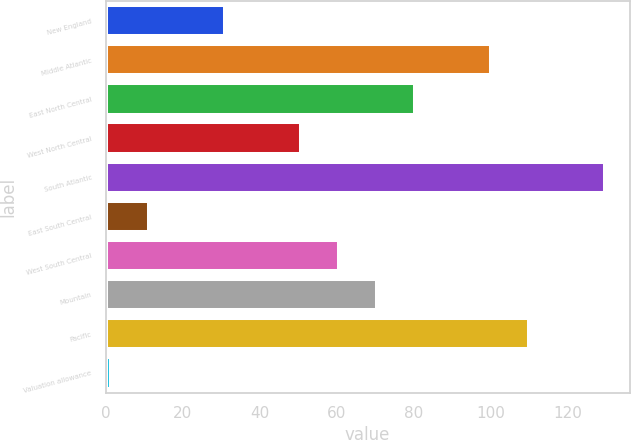Convert chart. <chart><loc_0><loc_0><loc_500><loc_500><bar_chart><fcel>New England<fcel>Middle Atlantic<fcel>East North Central<fcel>West North Central<fcel>South Atlantic<fcel>East South Central<fcel>West South Central<fcel>Mountain<fcel>Pacific<fcel>Valuation allowance<nl><fcel>30.98<fcel>100<fcel>80.28<fcel>50.7<fcel>129.58<fcel>11.26<fcel>60.56<fcel>70.42<fcel>109.86<fcel>1.4<nl></chart> 